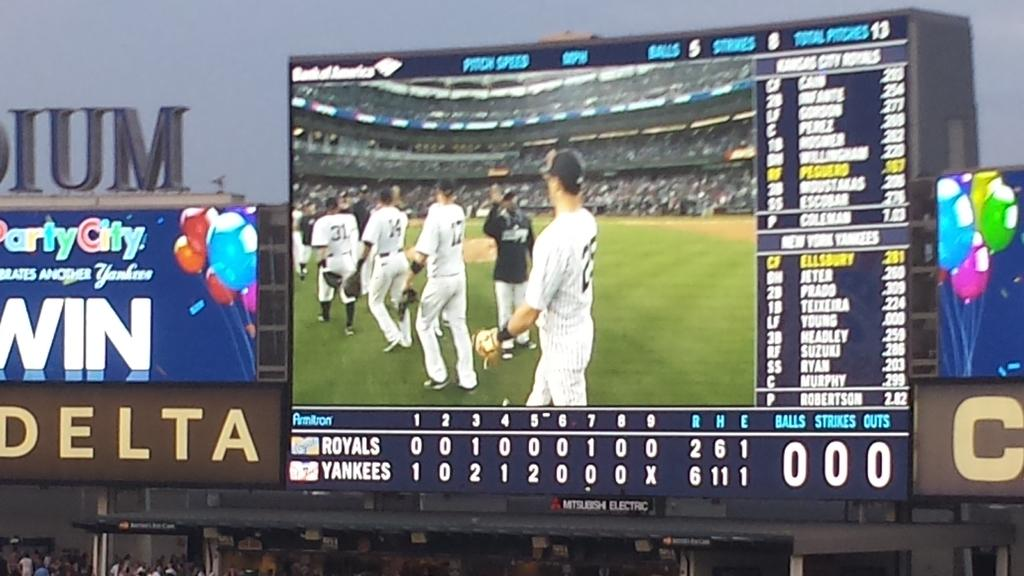Provide a one-sentence caption for the provided image. A scoreboard shows the Yankee players congratulating their teammates after the Yankees defeated the Royals 6-2. 